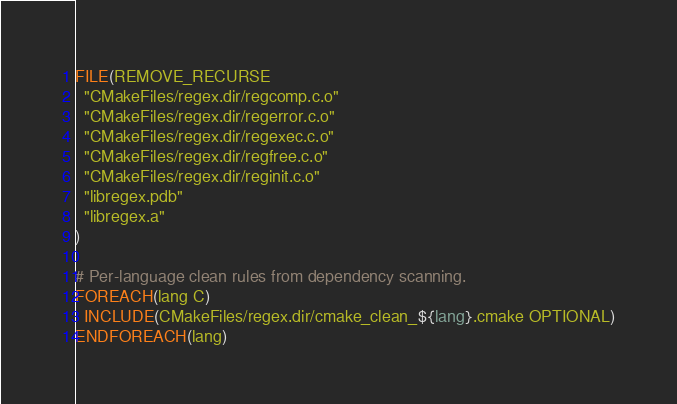<code> <loc_0><loc_0><loc_500><loc_500><_CMake_>FILE(REMOVE_RECURSE
  "CMakeFiles/regex.dir/regcomp.c.o"
  "CMakeFiles/regex.dir/regerror.c.o"
  "CMakeFiles/regex.dir/regexec.c.o"
  "CMakeFiles/regex.dir/regfree.c.o"
  "CMakeFiles/regex.dir/reginit.c.o"
  "libregex.pdb"
  "libregex.a"
)

# Per-language clean rules from dependency scanning.
FOREACH(lang C)
  INCLUDE(CMakeFiles/regex.dir/cmake_clean_${lang}.cmake OPTIONAL)
ENDFOREACH(lang)
</code> 